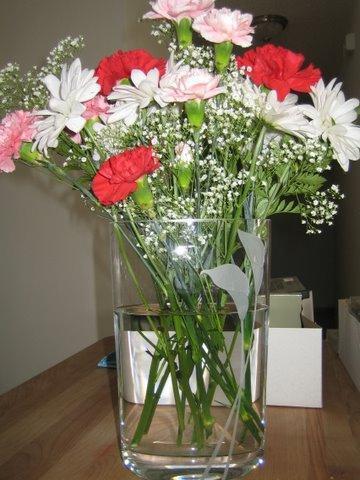How many people fit on each chair of the chairlift?
Give a very brief answer. 0. 